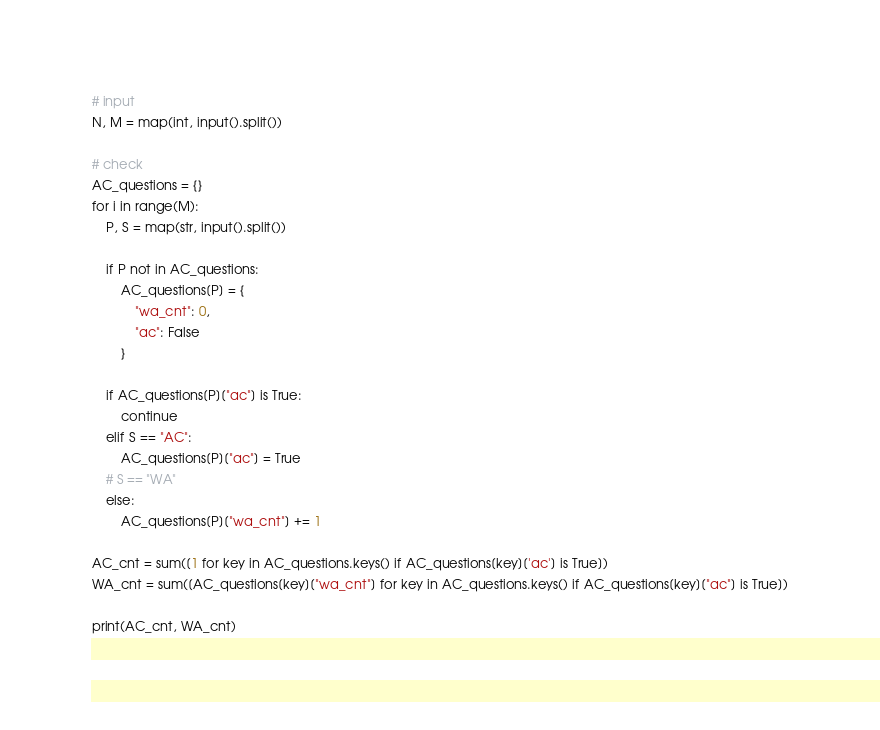<code> <loc_0><loc_0><loc_500><loc_500><_Python_># input
N, M = map(int, input().split())

# check
AC_questions = {}
for i in range(M):
    P, S = map(str, input().split())

    if P not in AC_questions:
        AC_questions[P] = {
            "wa_cnt": 0,
            "ac": False
        }

    if AC_questions[P]["ac"] is True:
        continue
    elif S == "AC":
        AC_questions[P]["ac"] = True
    # S == "WA"
    else:
        AC_questions[P]["wa_cnt"] += 1

AC_cnt = sum([1 for key in AC_questions.keys() if AC_questions[key]['ac'] is True])
WA_cnt = sum([AC_questions[key]["wa_cnt"] for key in AC_questions.keys() if AC_questions[key]["ac"] is True])

print(AC_cnt, WA_cnt)</code> 